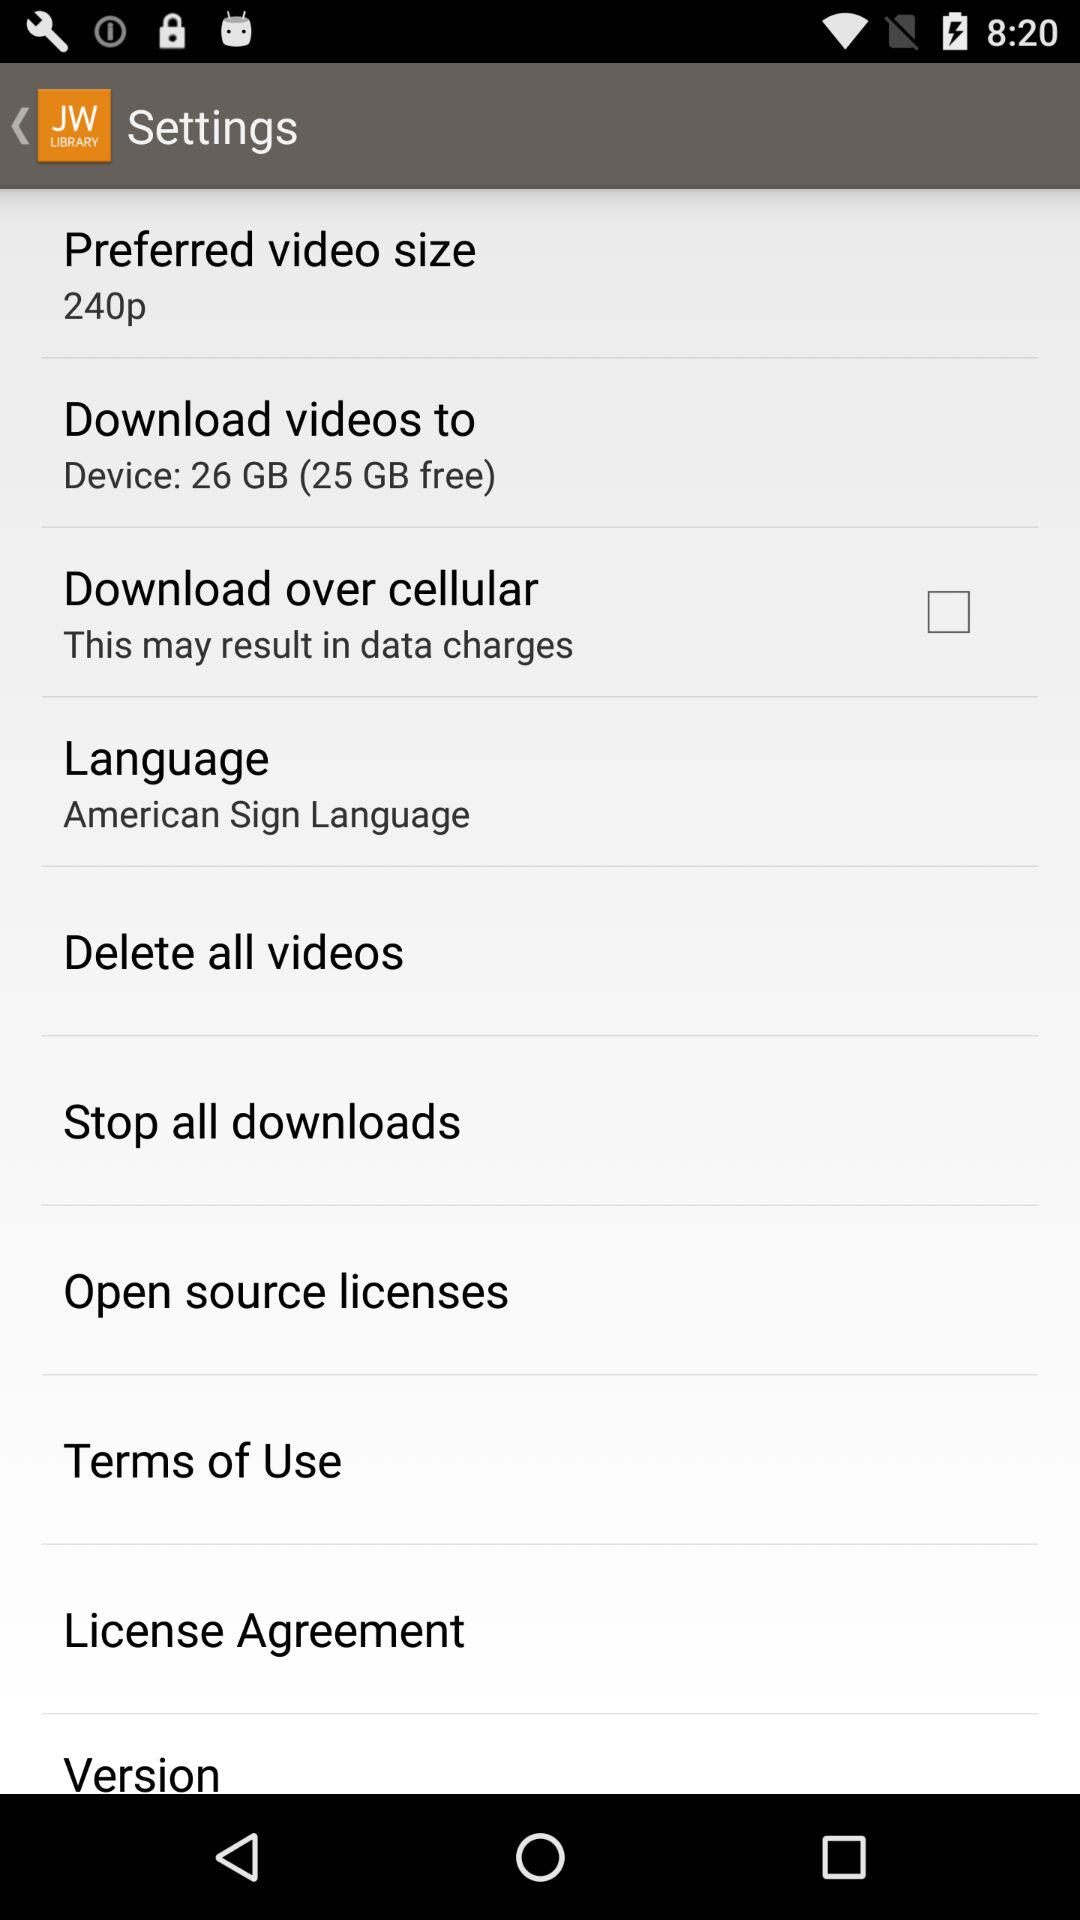What is the status of "Download over cellular"? The status is "off". 